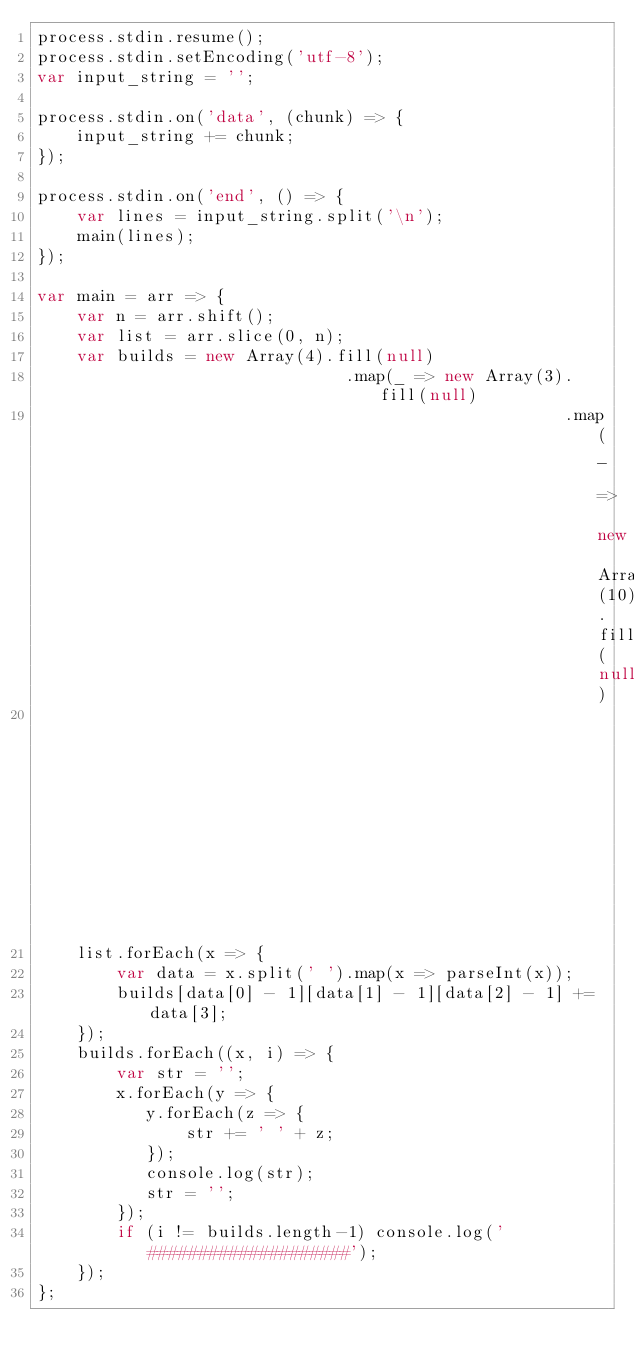Convert code to text. <code><loc_0><loc_0><loc_500><loc_500><_JavaScript_>process.stdin.resume();
process.stdin.setEncoding('utf-8');
var input_string = '';

process.stdin.on('data', (chunk) => {
    input_string += chunk;
});

process.stdin.on('end', () => {
    var lines = input_string.split('\n');
    main(lines);
});

var main = arr => {
    var n = arr.shift();
    var list = arr.slice(0, n);
    var builds = new Array(4).fill(null)
                               .map(_ => new Array(3).fill(null)
                                                     .map(_ => new Array(10).fill(null)
                                                                            .map(_ => 0)));
    list.forEach(x => {
        var data = x.split(' ').map(x => parseInt(x));
        builds[data[0] - 1][data[1] - 1][data[2] - 1] += data[3];
    });
    builds.forEach((x, i) => {
        var str = '';
        x.forEach(y => {
           y.forEach(z => {
               str += ' ' + z; 
           });
           console.log(str);
           str = '';
        });
        if (i != builds.length-1) console.log('####################');
    });
};</code> 